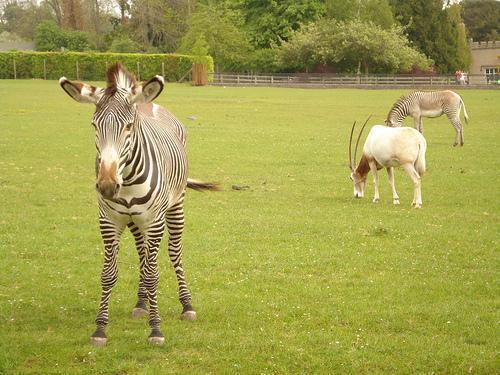How many zebras are there?
Give a very brief answer. 2. 